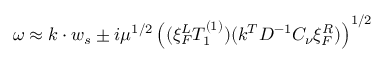Convert formula to latex. <formula><loc_0><loc_0><loc_500><loc_500>\omega \approx k \cdot w _ { s } \pm i \mu ^ { 1 / 2 } \left ( ( \xi _ { F } ^ { L } T _ { 1 } ^ { ( 1 ) } ) ( k ^ { T } D ^ { - 1 } C _ { \nu } \xi _ { F } ^ { R } ) \right ) ^ { 1 / 2 }</formula> 